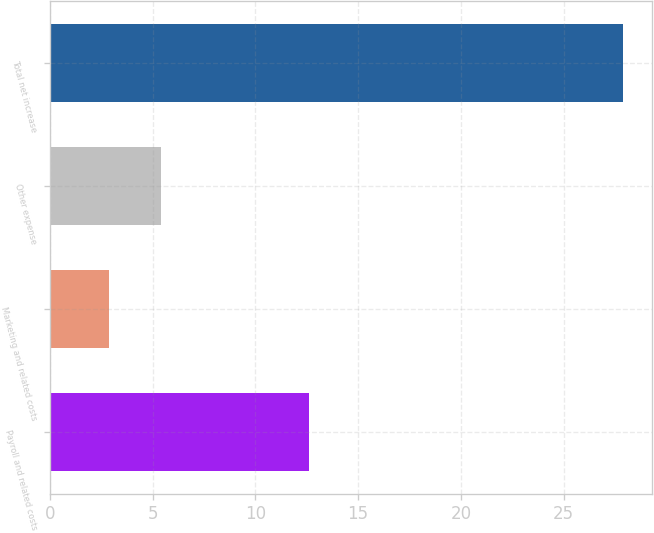<chart> <loc_0><loc_0><loc_500><loc_500><bar_chart><fcel>Payroll and related costs<fcel>Marketing and related costs<fcel>Other expense<fcel>Total net increase<nl><fcel>12.6<fcel>2.9<fcel>5.4<fcel>27.9<nl></chart> 